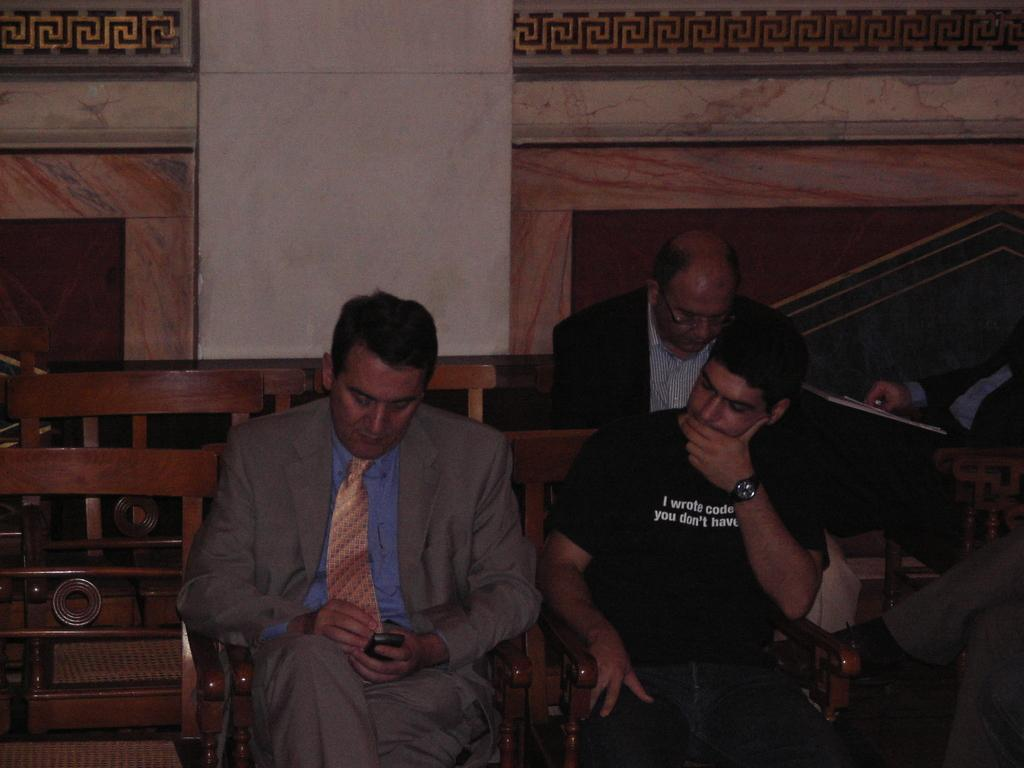What are the persons in the image doing? The persons in the image are sitting on chairs. What is the color of the chairs? The chairs are brown in color. What can be seen in the background of the image? There is a wall in the background of the image. What colors are present on the wall? The wall has cream, brown, and orange colors. What type of brush is being used by the person in the image? There is no brush present in the image; the persons are sitting on chairs. 